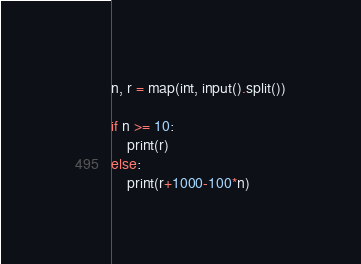Convert code to text. <code><loc_0><loc_0><loc_500><loc_500><_Python_>n, r = map(int, input().split())

if n >= 10:
    print(r)
else:
    print(r+1000-100*n)</code> 